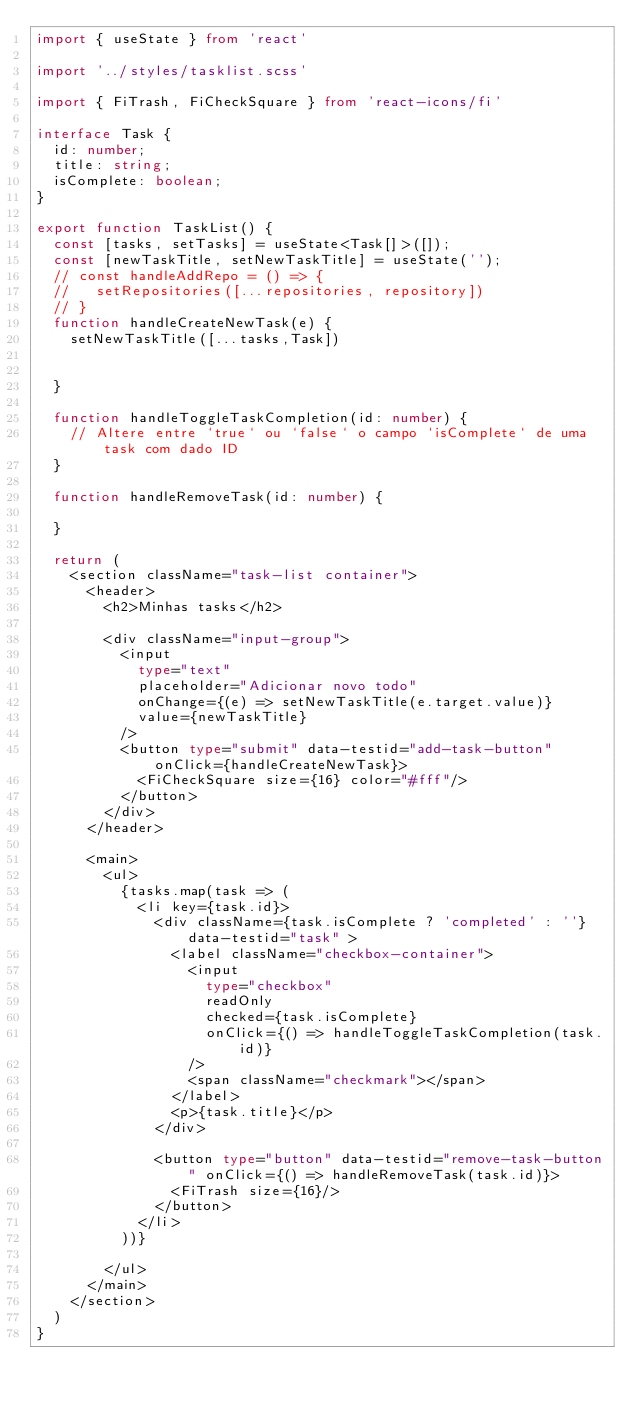<code> <loc_0><loc_0><loc_500><loc_500><_TypeScript_>import { useState } from 'react'

import '../styles/tasklist.scss'

import { FiTrash, FiCheckSquare } from 'react-icons/fi'

interface Task {
  id: number;
  title: string;
  isComplete: boolean;
}

export function TaskList() {
  const [tasks, setTasks] = useState<Task[]>([]);
  const [newTaskTitle, setNewTaskTitle] = useState('');
  // const handleAddRepo = () => {
  //   setRepositories([...repositories, repository])
  // }
  function handleCreateNewTask(e) {
    setNewTaskTitle([...tasks,Task])
    
    
  }

  function handleToggleTaskCompletion(id: number) {
    // Altere entre `true` ou `false` o campo `isComplete` de uma task com dado ID
  }

  function handleRemoveTask(id: number) {
    
  }

  return (
    <section className="task-list container">
      <header>
        <h2>Minhas tasks</h2>

        <div className="input-group">
          <input 
            type="text" 
            placeholder="Adicionar novo todo" 
            onChange={(e) => setNewTaskTitle(e.target.value)}
            value={newTaskTitle}
          />
          <button type="submit" data-testid="add-task-button" onClick={handleCreateNewTask}>
            <FiCheckSquare size={16} color="#fff"/>
          </button>
        </div>
      </header>

      <main>
        <ul>
          {tasks.map(task => (
            <li key={task.id}>
              <div className={task.isComplete ? 'completed' : ''} data-testid="task" >
                <label className="checkbox-container">
                  <input 
                    type="checkbox"
                    readOnly
                    checked={task.isComplete}
                    onClick={() => handleToggleTaskCompletion(task.id)}
                  />
                  <span className="checkmark"></span>
                </label>
                <p>{task.title}</p>
              </div>

              <button type="button" data-testid="remove-task-button" onClick={() => handleRemoveTask(task.id)}>
                <FiTrash size={16}/>
              </button>
            </li>
          ))}
          
        </ul>
      </main>
    </section>
  )
}</code> 